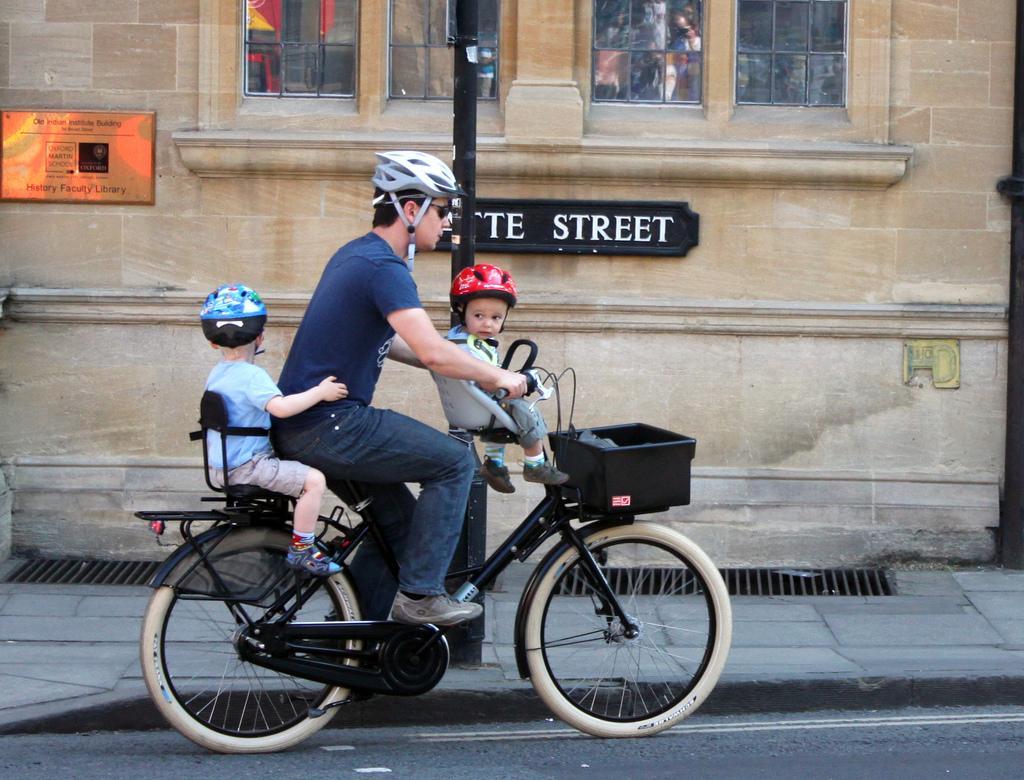How would you summarize this image in a sentence or two? The picture is taken on the road where one person is riding a bicycle and with him there are two children wearing red helmet and blue helmet. The person is wearing a helmet too beside him there is a building on the building there is text and there is one footpath beside the road. 